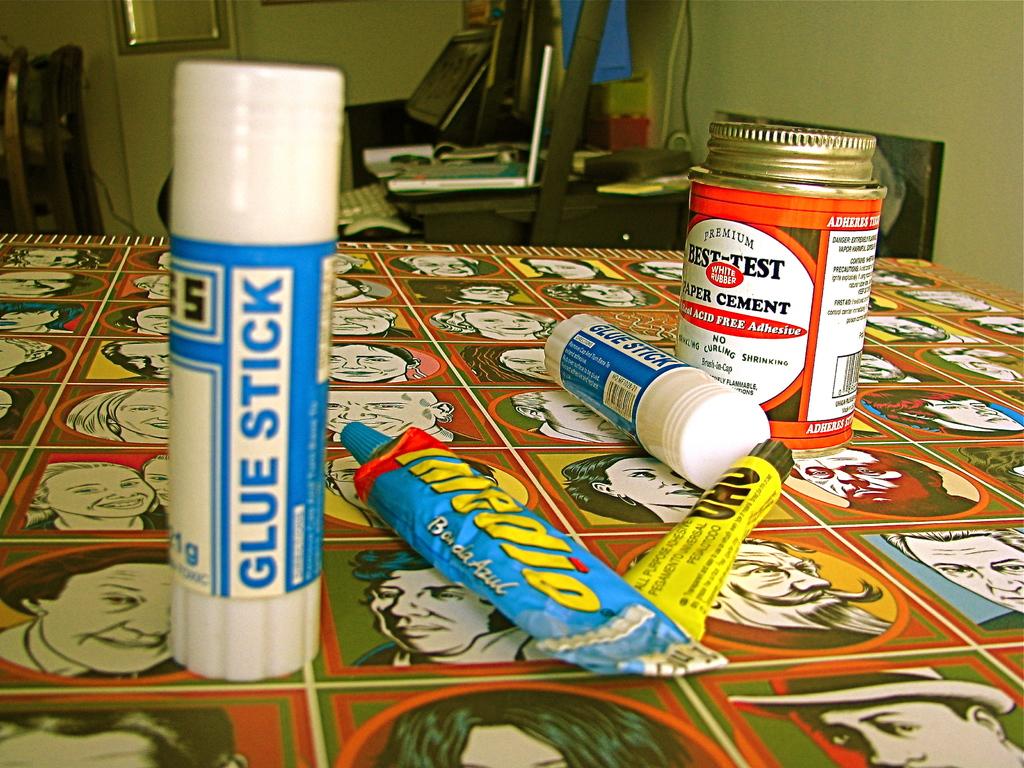What is that stick?
Offer a terse response. Glue. What is the second word on the object on the left?
Provide a short and direct response. Stick. 